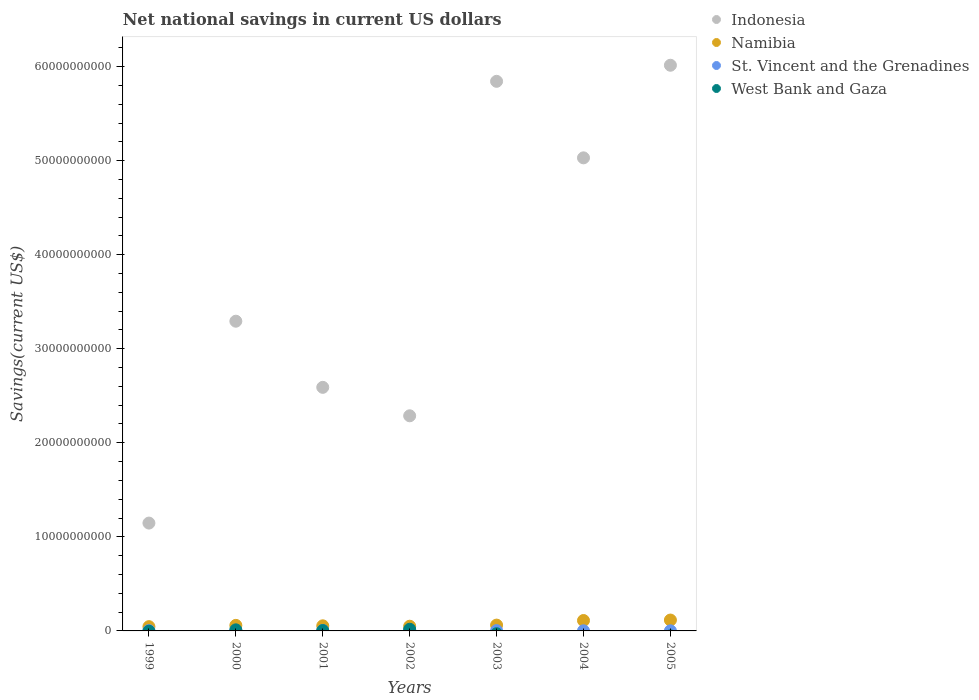How many different coloured dotlines are there?
Your answer should be compact. 4. Is the number of dotlines equal to the number of legend labels?
Give a very brief answer. No. What is the net national savings in St. Vincent and the Grenadines in 2000?
Offer a very short reply. 5.68e+07. Across all years, what is the maximum net national savings in West Bank and Gaza?
Offer a terse response. 1.78e+08. Across all years, what is the minimum net national savings in Indonesia?
Make the answer very short. 1.15e+1. In which year was the net national savings in Indonesia maximum?
Provide a succinct answer. 2005. What is the total net national savings in Indonesia in the graph?
Provide a short and direct response. 2.62e+11. What is the difference between the net national savings in Indonesia in 2002 and that in 2005?
Provide a short and direct response. -3.73e+1. What is the difference between the net national savings in Indonesia in 2004 and the net national savings in West Bank and Gaza in 2000?
Make the answer very short. 5.02e+1. What is the average net national savings in West Bank and Gaza per year?
Provide a succinct answer. 4.76e+07. In the year 2003, what is the difference between the net national savings in Namibia and net national savings in St. Vincent and the Grenadines?
Provide a succinct answer. 5.85e+08. In how many years, is the net national savings in Namibia greater than 56000000000 US$?
Offer a terse response. 0. What is the ratio of the net national savings in St. Vincent and the Grenadines in 2000 to that in 2001?
Keep it short and to the point. 1.23. What is the difference between the highest and the second highest net national savings in Indonesia?
Provide a short and direct response. 1.71e+09. What is the difference between the highest and the lowest net national savings in St. Vincent and the Grenadines?
Your answer should be compact. 4.45e+07. In how many years, is the net national savings in Namibia greater than the average net national savings in Namibia taken over all years?
Keep it short and to the point. 2. Is the sum of the net national savings in St. Vincent and the Grenadines in 2002 and 2004 greater than the maximum net national savings in Indonesia across all years?
Your answer should be very brief. No. Does the net national savings in Indonesia monotonically increase over the years?
Offer a very short reply. No. Is the net national savings in St. Vincent and the Grenadines strictly less than the net national savings in Namibia over the years?
Your answer should be compact. Yes. Are the values on the major ticks of Y-axis written in scientific E-notation?
Ensure brevity in your answer.  No. How many legend labels are there?
Provide a short and direct response. 4. How are the legend labels stacked?
Keep it short and to the point. Vertical. What is the title of the graph?
Give a very brief answer. Net national savings in current US dollars. What is the label or title of the X-axis?
Keep it short and to the point. Years. What is the label or title of the Y-axis?
Offer a very short reply. Savings(current US$). What is the Savings(current US$) of Indonesia in 1999?
Keep it short and to the point. 1.15e+1. What is the Savings(current US$) in Namibia in 1999?
Give a very brief answer. 4.54e+08. What is the Savings(current US$) of St. Vincent and the Grenadines in 1999?
Keep it short and to the point. 3.56e+07. What is the Savings(current US$) of Indonesia in 2000?
Your response must be concise. 3.29e+1. What is the Savings(current US$) of Namibia in 2000?
Offer a very short reply. 5.90e+08. What is the Savings(current US$) in St. Vincent and the Grenadines in 2000?
Your response must be concise. 5.68e+07. What is the Savings(current US$) in West Bank and Gaza in 2000?
Provide a succinct answer. 1.16e+08. What is the Savings(current US$) in Indonesia in 2001?
Keep it short and to the point. 2.59e+1. What is the Savings(current US$) in Namibia in 2001?
Make the answer very short. 5.42e+08. What is the Savings(current US$) in St. Vincent and the Grenadines in 2001?
Your answer should be compact. 4.61e+07. What is the Savings(current US$) of West Bank and Gaza in 2001?
Ensure brevity in your answer.  3.91e+07. What is the Savings(current US$) in Indonesia in 2002?
Ensure brevity in your answer.  2.29e+1. What is the Savings(current US$) of Namibia in 2002?
Your answer should be very brief. 5.00e+08. What is the Savings(current US$) in St. Vincent and the Grenadines in 2002?
Offer a very short reply. 4.76e+07. What is the Savings(current US$) of West Bank and Gaza in 2002?
Give a very brief answer. 1.78e+08. What is the Savings(current US$) in Indonesia in 2003?
Your response must be concise. 5.84e+1. What is the Savings(current US$) in Namibia in 2003?
Keep it short and to the point. 6.18e+08. What is the Savings(current US$) of St. Vincent and the Grenadines in 2003?
Keep it short and to the point. 3.32e+07. What is the Savings(current US$) in Indonesia in 2004?
Ensure brevity in your answer.  5.03e+1. What is the Savings(current US$) in Namibia in 2004?
Provide a short and direct response. 1.11e+09. What is the Savings(current US$) of St. Vincent and the Grenadines in 2004?
Offer a very short reply. 1.34e+07. What is the Savings(current US$) in West Bank and Gaza in 2004?
Provide a short and direct response. 0. What is the Savings(current US$) in Indonesia in 2005?
Offer a very short reply. 6.01e+1. What is the Savings(current US$) of Namibia in 2005?
Give a very brief answer. 1.16e+09. What is the Savings(current US$) in St. Vincent and the Grenadines in 2005?
Your answer should be very brief. 1.23e+07. Across all years, what is the maximum Savings(current US$) in Indonesia?
Provide a succinct answer. 6.01e+1. Across all years, what is the maximum Savings(current US$) in Namibia?
Your response must be concise. 1.16e+09. Across all years, what is the maximum Savings(current US$) in St. Vincent and the Grenadines?
Your answer should be compact. 5.68e+07. Across all years, what is the maximum Savings(current US$) in West Bank and Gaza?
Provide a short and direct response. 1.78e+08. Across all years, what is the minimum Savings(current US$) in Indonesia?
Ensure brevity in your answer.  1.15e+1. Across all years, what is the minimum Savings(current US$) in Namibia?
Ensure brevity in your answer.  4.54e+08. Across all years, what is the minimum Savings(current US$) in St. Vincent and the Grenadines?
Offer a terse response. 1.23e+07. Across all years, what is the minimum Savings(current US$) of West Bank and Gaza?
Your answer should be compact. 0. What is the total Savings(current US$) of Indonesia in the graph?
Provide a short and direct response. 2.62e+11. What is the total Savings(current US$) of Namibia in the graph?
Make the answer very short. 4.97e+09. What is the total Savings(current US$) of St. Vincent and the Grenadines in the graph?
Ensure brevity in your answer.  2.45e+08. What is the total Savings(current US$) in West Bank and Gaza in the graph?
Make the answer very short. 3.33e+08. What is the difference between the Savings(current US$) of Indonesia in 1999 and that in 2000?
Keep it short and to the point. -2.15e+1. What is the difference between the Savings(current US$) of Namibia in 1999 and that in 2000?
Give a very brief answer. -1.36e+08. What is the difference between the Savings(current US$) of St. Vincent and the Grenadines in 1999 and that in 2000?
Offer a terse response. -2.12e+07. What is the difference between the Savings(current US$) in Indonesia in 1999 and that in 2001?
Offer a very short reply. -1.44e+1. What is the difference between the Savings(current US$) of Namibia in 1999 and that in 2001?
Give a very brief answer. -8.80e+07. What is the difference between the Savings(current US$) of St. Vincent and the Grenadines in 1999 and that in 2001?
Ensure brevity in your answer.  -1.05e+07. What is the difference between the Savings(current US$) of Indonesia in 1999 and that in 2002?
Your answer should be compact. -1.14e+1. What is the difference between the Savings(current US$) in Namibia in 1999 and that in 2002?
Offer a terse response. -4.55e+07. What is the difference between the Savings(current US$) in St. Vincent and the Grenadines in 1999 and that in 2002?
Offer a terse response. -1.20e+07. What is the difference between the Savings(current US$) in Indonesia in 1999 and that in 2003?
Provide a succinct answer. -4.70e+1. What is the difference between the Savings(current US$) of Namibia in 1999 and that in 2003?
Ensure brevity in your answer.  -1.64e+08. What is the difference between the Savings(current US$) of St. Vincent and the Grenadines in 1999 and that in 2003?
Offer a terse response. 2.38e+06. What is the difference between the Savings(current US$) in Indonesia in 1999 and that in 2004?
Your response must be concise. -3.88e+1. What is the difference between the Savings(current US$) in Namibia in 1999 and that in 2004?
Keep it short and to the point. -6.52e+08. What is the difference between the Savings(current US$) in St. Vincent and the Grenadines in 1999 and that in 2004?
Ensure brevity in your answer.  2.22e+07. What is the difference between the Savings(current US$) in Indonesia in 1999 and that in 2005?
Offer a very short reply. -4.87e+1. What is the difference between the Savings(current US$) of Namibia in 1999 and that in 2005?
Keep it short and to the point. -7.01e+08. What is the difference between the Savings(current US$) in St. Vincent and the Grenadines in 1999 and that in 2005?
Ensure brevity in your answer.  2.33e+07. What is the difference between the Savings(current US$) of Indonesia in 2000 and that in 2001?
Keep it short and to the point. 7.03e+09. What is the difference between the Savings(current US$) in Namibia in 2000 and that in 2001?
Your answer should be compact. 4.76e+07. What is the difference between the Savings(current US$) in St. Vincent and the Grenadines in 2000 and that in 2001?
Your response must be concise. 1.07e+07. What is the difference between the Savings(current US$) in West Bank and Gaza in 2000 and that in 2001?
Make the answer very short. 7.66e+07. What is the difference between the Savings(current US$) of Indonesia in 2000 and that in 2002?
Your answer should be very brief. 1.01e+1. What is the difference between the Savings(current US$) in Namibia in 2000 and that in 2002?
Provide a succinct answer. 9.01e+07. What is the difference between the Savings(current US$) in St. Vincent and the Grenadines in 2000 and that in 2002?
Make the answer very short. 9.15e+06. What is the difference between the Savings(current US$) of West Bank and Gaza in 2000 and that in 2002?
Your answer should be compact. -6.26e+07. What is the difference between the Savings(current US$) of Indonesia in 2000 and that in 2003?
Offer a very short reply. -2.55e+1. What is the difference between the Savings(current US$) of Namibia in 2000 and that in 2003?
Make the answer very short. -2.83e+07. What is the difference between the Savings(current US$) of St. Vincent and the Grenadines in 2000 and that in 2003?
Make the answer very short. 2.36e+07. What is the difference between the Savings(current US$) of Indonesia in 2000 and that in 2004?
Provide a short and direct response. -1.74e+1. What is the difference between the Savings(current US$) of Namibia in 2000 and that in 2004?
Your answer should be very brief. -5.17e+08. What is the difference between the Savings(current US$) of St. Vincent and the Grenadines in 2000 and that in 2004?
Make the answer very short. 4.34e+07. What is the difference between the Savings(current US$) of Indonesia in 2000 and that in 2005?
Offer a very short reply. -2.72e+1. What is the difference between the Savings(current US$) in Namibia in 2000 and that in 2005?
Your answer should be very brief. -5.66e+08. What is the difference between the Savings(current US$) in St. Vincent and the Grenadines in 2000 and that in 2005?
Provide a short and direct response. 4.45e+07. What is the difference between the Savings(current US$) of Indonesia in 2001 and that in 2002?
Ensure brevity in your answer.  3.03e+09. What is the difference between the Savings(current US$) in Namibia in 2001 and that in 2002?
Your answer should be very brief. 4.25e+07. What is the difference between the Savings(current US$) in St. Vincent and the Grenadines in 2001 and that in 2002?
Provide a succinct answer. -1.51e+06. What is the difference between the Savings(current US$) of West Bank and Gaza in 2001 and that in 2002?
Keep it short and to the point. -1.39e+08. What is the difference between the Savings(current US$) in Indonesia in 2001 and that in 2003?
Your response must be concise. -3.25e+1. What is the difference between the Savings(current US$) of Namibia in 2001 and that in 2003?
Ensure brevity in your answer.  -7.59e+07. What is the difference between the Savings(current US$) of St. Vincent and the Grenadines in 2001 and that in 2003?
Ensure brevity in your answer.  1.29e+07. What is the difference between the Savings(current US$) in Indonesia in 2001 and that in 2004?
Offer a terse response. -2.44e+1. What is the difference between the Savings(current US$) in Namibia in 2001 and that in 2004?
Make the answer very short. -5.64e+08. What is the difference between the Savings(current US$) in St. Vincent and the Grenadines in 2001 and that in 2004?
Your answer should be very brief. 3.27e+07. What is the difference between the Savings(current US$) in Indonesia in 2001 and that in 2005?
Make the answer very short. -3.42e+1. What is the difference between the Savings(current US$) of Namibia in 2001 and that in 2005?
Make the answer very short. -6.13e+08. What is the difference between the Savings(current US$) of St. Vincent and the Grenadines in 2001 and that in 2005?
Give a very brief answer. 3.38e+07. What is the difference between the Savings(current US$) in Indonesia in 2002 and that in 2003?
Ensure brevity in your answer.  -3.56e+1. What is the difference between the Savings(current US$) in Namibia in 2002 and that in 2003?
Give a very brief answer. -1.18e+08. What is the difference between the Savings(current US$) of St. Vincent and the Grenadines in 2002 and that in 2003?
Your answer should be very brief. 1.44e+07. What is the difference between the Savings(current US$) in Indonesia in 2002 and that in 2004?
Your answer should be compact. -2.74e+1. What is the difference between the Savings(current US$) of Namibia in 2002 and that in 2004?
Offer a very short reply. -6.07e+08. What is the difference between the Savings(current US$) in St. Vincent and the Grenadines in 2002 and that in 2004?
Ensure brevity in your answer.  3.42e+07. What is the difference between the Savings(current US$) in Indonesia in 2002 and that in 2005?
Your answer should be very brief. -3.73e+1. What is the difference between the Savings(current US$) in Namibia in 2002 and that in 2005?
Offer a terse response. -6.56e+08. What is the difference between the Savings(current US$) in St. Vincent and the Grenadines in 2002 and that in 2005?
Ensure brevity in your answer.  3.53e+07. What is the difference between the Savings(current US$) in Indonesia in 2003 and that in 2004?
Your answer should be compact. 8.14e+09. What is the difference between the Savings(current US$) of Namibia in 2003 and that in 2004?
Make the answer very short. -4.88e+08. What is the difference between the Savings(current US$) of St. Vincent and the Grenadines in 2003 and that in 2004?
Your answer should be very brief. 1.98e+07. What is the difference between the Savings(current US$) in Indonesia in 2003 and that in 2005?
Provide a succinct answer. -1.71e+09. What is the difference between the Savings(current US$) in Namibia in 2003 and that in 2005?
Offer a terse response. -5.37e+08. What is the difference between the Savings(current US$) in St. Vincent and the Grenadines in 2003 and that in 2005?
Offer a very short reply. 2.09e+07. What is the difference between the Savings(current US$) of Indonesia in 2004 and that in 2005?
Offer a terse response. -9.85e+09. What is the difference between the Savings(current US$) in Namibia in 2004 and that in 2005?
Make the answer very short. -4.90e+07. What is the difference between the Savings(current US$) of St. Vincent and the Grenadines in 2004 and that in 2005?
Give a very brief answer. 1.10e+06. What is the difference between the Savings(current US$) in Indonesia in 1999 and the Savings(current US$) in Namibia in 2000?
Your answer should be compact. 1.09e+1. What is the difference between the Savings(current US$) of Indonesia in 1999 and the Savings(current US$) of St. Vincent and the Grenadines in 2000?
Offer a terse response. 1.14e+1. What is the difference between the Savings(current US$) in Indonesia in 1999 and the Savings(current US$) in West Bank and Gaza in 2000?
Keep it short and to the point. 1.14e+1. What is the difference between the Savings(current US$) of Namibia in 1999 and the Savings(current US$) of St. Vincent and the Grenadines in 2000?
Provide a short and direct response. 3.97e+08. What is the difference between the Savings(current US$) in Namibia in 1999 and the Savings(current US$) in West Bank and Gaza in 2000?
Your answer should be compact. 3.39e+08. What is the difference between the Savings(current US$) in St. Vincent and the Grenadines in 1999 and the Savings(current US$) in West Bank and Gaza in 2000?
Offer a very short reply. -8.01e+07. What is the difference between the Savings(current US$) of Indonesia in 1999 and the Savings(current US$) of Namibia in 2001?
Your answer should be very brief. 1.09e+1. What is the difference between the Savings(current US$) of Indonesia in 1999 and the Savings(current US$) of St. Vincent and the Grenadines in 2001?
Your response must be concise. 1.14e+1. What is the difference between the Savings(current US$) of Indonesia in 1999 and the Savings(current US$) of West Bank and Gaza in 2001?
Your answer should be very brief. 1.14e+1. What is the difference between the Savings(current US$) in Namibia in 1999 and the Savings(current US$) in St. Vincent and the Grenadines in 2001?
Your answer should be compact. 4.08e+08. What is the difference between the Savings(current US$) of Namibia in 1999 and the Savings(current US$) of West Bank and Gaza in 2001?
Your response must be concise. 4.15e+08. What is the difference between the Savings(current US$) in St. Vincent and the Grenadines in 1999 and the Savings(current US$) in West Bank and Gaza in 2001?
Make the answer very short. -3.47e+06. What is the difference between the Savings(current US$) of Indonesia in 1999 and the Savings(current US$) of Namibia in 2002?
Offer a very short reply. 1.10e+1. What is the difference between the Savings(current US$) of Indonesia in 1999 and the Savings(current US$) of St. Vincent and the Grenadines in 2002?
Your answer should be very brief. 1.14e+1. What is the difference between the Savings(current US$) of Indonesia in 1999 and the Savings(current US$) of West Bank and Gaza in 2002?
Your answer should be compact. 1.13e+1. What is the difference between the Savings(current US$) in Namibia in 1999 and the Savings(current US$) in St. Vincent and the Grenadines in 2002?
Offer a terse response. 4.07e+08. What is the difference between the Savings(current US$) of Namibia in 1999 and the Savings(current US$) of West Bank and Gaza in 2002?
Provide a short and direct response. 2.76e+08. What is the difference between the Savings(current US$) of St. Vincent and the Grenadines in 1999 and the Savings(current US$) of West Bank and Gaza in 2002?
Ensure brevity in your answer.  -1.43e+08. What is the difference between the Savings(current US$) of Indonesia in 1999 and the Savings(current US$) of Namibia in 2003?
Provide a succinct answer. 1.08e+1. What is the difference between the Savings(current US$) of Indonesia in 1999 and the Savings(current US$) of St. Vincent and the Grenadines in 2003?
Your answer should be very brief. 1.14e+1. What is the difference between the Savings(current US$) of Namibia in 1999 and the Savings(current US$) of St. Vincent and the Grenadines in 2003?
Make the answer very short. 4.21e+08. What is the difference between the Savings(current US$) of Indonesia in 1999 and the Savings(current US$) of Namibia in 2004?
Make the answer very short. 1.04e+1. What is the difference between the Savings(current US$) in Indonesia in 1999 and the Savings(current US$) in St. Vincent and the Grenadines in 2004?
Your answer should be compact. 1.15e+1. What is the difference between the Savings(current US$) of Namibia in 1999 and the Savings(current US$) of St. Vincent and the Grenadines in 2004?
Provide a short and direct response. 4.41e+08. What is the difference between the Savings(current US$) in Indonesia in 1999 and the Savings(current US$) in Namibia in 2005?
Provide a short and direct response. 1.03e+1. What is the difference between the Savings(current US$) in Indonesia in 1999 and the Savings(current US$) in St. Vincent and the Grenadines in 2005?
Provide a short and direct response. 1.15e+1. What is the difference between the Savings(current US$) of Namibia in 1999 and the Savings(current US$) of St. Vincent and the Grenadines in 2005?
Ensure brevity in your answer.  4.42e+08. What is the difference between the Savings(current US$) in Indonesia in 2000 and the Savings(current US$) in Namibia in 2001?
Your response must be concise. 3.24e+1. What is the difference between the Savings(current US$) of Indonesia in 2000 and the Savings(current US$) of St. Vincent and the Grenadines in 2001?
Your response must be concise. 3.29e+1. What is the difference between the Savings(current US$) in Indonesia in 2000 and the Savings(current US$) in West Bank and Gaza in 2001?
Ensure brevity in your answer.  3.29e+1. What is the difference between the Savings(current US$) in Namibia in 2000 and the Savings(current US$) in St. Vincent and the Grenadines in 2001?
Offer a terse response. 5.44e+08. What is the difference between the Savings(current US$) of Namibia in 2000 and the Savings(current US$) of West Bank and Gaza in 2001?
Ensure brevity in your answer.  5.51e+08. What is the difference between the Savings(current US$) in St. Vincent and the Grenadines in 2000 and the Savings(current US$) in West Bank and Gaza in 2001?
Make the answer very short. 1.77e+07. What is the difference between the Savings(current US$) in Indonesia in 2000 and the Savings(current US$) in Namibia in 2002?
Your response must be concise. 3.24e+1. What is the difference between the Savings(current US$) in Indonesia in 2000 and the Savings(current US$) in St. Vincent and the Grenadines in 2002?
Provide a short and direct response. 3.29e+1. What is the difference between the Savings(current US$) of Indonesia in 2000 and the Savings(current US$) of West Bank and Gaza in 2002?
Offer a very short reply. 3.27e+1. What is the difference between the Savings(current US$) of Namibia in 2000 and the Savings(current US$) of St. Vincent and the Grenadines in 2002?
Keep it short and to the point. 5.42e+08. What is the difference between the Savings(current US$) in Namibia in 2000 and the Savings(current US$) in West Bank and Gaza in 2002?
Provide a succinct answer. 4.12e+08. What is the difference between the Savings(current US$) in St. Vincent and the Grenadines in 2000 and the Savings(current US$) in West Bank and Gaza in 2002?
Ensure brevity in your answer.  -1.22e+08. What is the difference between the Savings(current US$) in Indonesia in 2000 and the Savings(current US$) in Namibia in 2003?
Provide a succinct answer. 3.23e+1. What is the difference between the Savings(current US$) in Indonesia in 2000 and the Savings(current US$) in St. Vincent and the Grenadines in 2003?
Ensure brevity in your answer.  3.29e+1. What is the difference between the Savings(current US$) of Namibia in 2000 and the Savings(current US$) of St. Vincent and the Grenadines in 2003?
Offer a very short reply. 5.57e+08. What is the difference between the Savings(current US$) of Indonesia in 2000 and the Savings(current US$) of Namibia in 2004?
Offer a terse response. 3.18e+1. What is the difference between the Savings(current US$) of Indonesia in 2000 and the Savings(current US$) of St. Vincent and the Grenadines in 2004?
Offer a very short reply. 3.29e+1. What is the difference between the Savings(current US$) in Namibia in 2000 and the Savings(current US$) in St. Vincent and the Grenadines in 2004?
Keep it short and to the point. 5.76e+08. What is the difference between the Savings(current US$) of Indonesia in 2000 and the Savings(current US$) of Namibia in 2005?
Ensure brevity in your answer.  3.18e+1. What is the difference between the Savings(current US$) of Indonesia in 2000 and the Savings(current US$) of St. Vincent and the Grenadines in 2005?
Your response must be concise. 3.29e+1. What is the difference between the Savings(current US$) of Namibia in 2000 and the Savings(current US$) of St. Vincent and the Grenadines in 2005?
Offer a very short reply. 5.78e+08. What is the difference between the Savings(current US$) in Indonesia in 2001 and the Savings(current US$) in Namibia in 2002?
Keep it short and to the point. 2.54e+1. What is the difference between the Savings(current US$) in Indonesia in 2001 and the Savings(current US$) in St. Vincent and the Grenadines in 2002?
Keep it short and to the point. 2.58e+1. What is the difference between the Savings(current US$) of Indonesia in 2001 and the Savings(current US$) of West Bank and Gaza in 2002?
Your response must be concise. 2.57e+1. What is the difference between the Savings(current US$) of Namibia in 2001 and the Savings(current US$) of St. Vincent and the Grenadines in 2002?
Offer a very short reply. 4.95e+08. What is the difference between the Savings(current US$) in Namibia in 2001 and the Savings(current US$) in West Bank and Gaza in 2002?
Make the answer very short. 3.64e+08. What is the difference between the Savings(current US$) in St. Vincent and the Grenadines in 2001 and the Savings(current US$) in West Bank and Gaza in 2002?
Give a very brief answer. -1.32e+08. What is the difference between the Savings(current US$) of Indonesia in 2001 and the Savings(current US$) of Namibia in 2003?
Your answer should be compact. 2.53e+1. What is the difference between the Savings(current US$) in Indonesia in 2001 and the Savings(current US$) in St. Vincent and the Grenadines in 2003?
Make the answer very short. 2.59e+1. What is the difference between the Savings(current US$) of Namibia in 2001 and the Savings(current US$) of St. Vincent and the Grenadines in 2003?
Provide a succinct answer. 5.09e+08. What is the difference between the Savings(current US$) in Indonesia in 2001 and the Savings(current US$) in Namibia in 2004?
Make the answer very short. 2.48e+1. What is the difference between the Savings(current US$) of Indonesia in 2001 and the Savings(current US$) of St. Vincent and the Grenadines in 2004?
Keep it short and to the point. 2.59e+1. What is the difference between the Savings(current US$) of Namibia in 2001 and the Savings(current US$) of St. Vincent and the Grenadines in 2004?
Your answer should be compact. 5.29e+08. What is the difference between the Savings(current US$) in Indonesia in 2001 and the Savings(current US$) in Namibia in 2005?
Provide a succinct answer. 2.47e+1. What is the difference between the Savings(current US$) of Indonesia in 2001 and the Savings(current US$) of St. Vincent and the Grenadines in 2005?
Keep it short and to the point. 2.59e+1. What is the difference between the Savings(current US$) in Namibia in 2001 and the Savings(current US$) in St. Vincent and the Grenadines in 2005?
Keep it short and to the point. 5.30e+08. What is the difference between the Savings(current US$) of Indonesia in 2002 and the Savings(current US$) of Namibia in 2003?
Provide a short and direct response. 2.23e+1. What is the difference between the Savings(current US$) of Indonesia in 2002 and the Savings(current US$) of St. Vincent and the Grenadines in 2003?
Your answer should be compact. 2.28e+1. What is the difference between the Savings(current US$) of Namibia in 2002 and the Savings(current US$) of St. Vincent and the Grenadines in 2003?
Your answer should be very brief. 4.67e+08. What is the difference between the Savings(current US$) in Indonesia in 2002 and the Savings(current US$) in Namibia in 2004?
Provide a succinct answer. 2.18e+1. What is the difference between the Savings(current US$) of Indonesia in 2002 and the Savings(current US$) of St. Vincent and the Grenadines in 2004?
Offer a very short reply. 2.29e+1. What is the difference between the Savings(current US$) in Namibia in 2002 and the Savings(current US$) in St. Vincent and the Grenadines in 2004?
Your answer should be very brief. 4.86e+08. What is the difference between the Savings(current US$) of Indonesia in 2002 and the Savings(current US$) of Namibia in 2005?
Provide a short and direct response. 2.17e+1. What is the difference between the Savings(current US$) of Indonesia in 2002 and the Savings(current US$) of St. Vincent and the Grenadines in 2005?
Provide a short and direct response. 2.29e+1. What is the difference between the Savings(current US$) in Namibia in 2002 and the Savings(current US$) in St. Vincent and the Grenadines in 2005?
Your answer should be very brief. 4.87e+08. What is the difference between the Savings(current US$) in Indonesia in 2003 and the Savings(current US$) in Namibia in 2004?
Provide a succinct answer. 5.73e+1. What is the difference between the Savings(current US$) of Indonesia in 2003 and the Savings(current US$) of St. Vincent and the Grenadines in 2004?
Make the answer very short. 5.84e+1. What is the difference between the Savings(current US$) in Namibia in 2003 and the Savings(current US$) in St. Vincent and the Grenadines in 2004?
Make the answer very short. 6.05e+08. What is the difference between the Savings(current US$) in Indonesia in 2003 and the Savings(current US$) in Namibia in 2005?
Your answer should be compact. 5.73e+1. What is the difference between the Savings(current US$) of Indonesia in 2003 and the Savings(current US$) of St. Vincent and the Grenadines in 2005?
Provide a short and direct response. 5.84e+1. What is the difference between the Savings(current US$) of Namibia in 2003 and the Savings(current US$) of St. Vincent and the Grenadines in 2005?
Make the answer very short. 6.06e+08. What is the difference between the Savings(current US$) in Indonesia in 2004 and the Savings(current US$) in Namibia in 2005?
Your answer should be compact. 4.91e+1. What is the difference between the Savings(current US$) in Indonesia in 2004 and the Savings(current US$) in St. Vincent and the Grenadines in 2005?
Give a very brief answer. 5.03e+1. What is the difference between the Savings(current US$) in Namibia in 2004 and the Savings(current US$) in St. Vincent and the Grenadines in 2005?
Your answer should be very brief. 1.09e+09. What is the average Savings(current US$) in Indonesia per year?
Provide a succinct answer. 3.74e+1. What is the average Savings(current US$) of Namibia per year?
Give a very brief answer. 7.09e+08. What is the average Savings(current US$) in St. Vincent and the Grenadines per year?
Your answer should be very brief. 3.50e+07. What is the average Savings(current US$) of West Bank and Gaza per year?
Give a very brief answer. 4.76e+07. In the year 1999, what is the difference between the Savings(current US$) in Indonesia and Savings(current US$) in Namibia?
Provide a short and direct response. 1.10e+1. In the year 1999, what is the difference between the Savings(current US$) of Indonesia and Savings(current US$) of St. Vincent and the Grenadines?
Provide a short and direct response. 1.14e+1. In the year 1999, what is the difference between the Savings(current US$) of Namibia and Savings(current US$) of St. Vincent and the Grenadines?
Keep it short and to the point. 4.19e+08. In the year 2000, what is the difference between the Savings(current US$) of Indonesia and Savings(current US$) of Namibia?
Offer a very short reply. 3.23e+1. In the year 2000, what is the difference between the Savings(current US$) of Indonesia and Savings(current US$) of St. Vincent and the Grenadines?
Your answer should be compact. 3.29e+1. In the year 2000, what is the difference between the Savings(current US$) of Indonesia and Savings(current US$) of West Bank and Gaza?
Provide a short and direct response. 3.28e+1. In the year 2000, what is the difference between the Savings(current US$) in Namibia and Savings(current US$) in St. Vincent and the Grenadines?
Your answer should be very brief. 5.33e+08. In the year 2000, what is the difference between the Savings(current US$) of Namibia and Savings(current US$) of West Bank and Gaza?
Ensure brevity in your answer.  4.74e+08. In the year 2000, what is the difference between the Savings(current US$) of St. Vincent and the Grenadines and Savings(current US$) of West Bank and Gaza?
Your answer should be very brief. -5.89e+07. In the year 2001, what is the difference between the Savings(current US$) in Indonesia and Savings(current US$) in Namibia?
Your answer should be compact. 2.54e+1. In the year 2001, what is the difference between the Savings(current US$) in Indonesia and Savings(current US$) in St. Vincent and the Grenadines?
Make the answer very short. 2.59e+1. In the year 2001, what is the difference between the Savings(current US$) in Indonesia and Savings(current US$) in West Bank and Gaza?
Provide a short and direct response. 2.59e+1. In the year 2001, what is the difference between the Savings(current US$) in Namibia and Savings(current US$) in St. Vincent and the Grenadines?
Offer a terse response. 4.96e+08. In the year 2001, what is the difference between the Savings(current US$) in Namibia and Savings(current US$) in West Bank and Gaza?
Your answer should be compact. 5.03e+08. In the year 2001, what is the difference between the Savings(current US$) of St. Vincent and the Grenadines and Savings(current US$) of West Bank and Gaza?
Provide a short and direct response. 7.04e+06. In the year 2002, what is the difference between the Savings(current US$) in Indonesia and Savings(current US$) in Namibia?
Offer a very short reply. 2.24e+1. In the year 2002, what is the difference between the Savings(current US$) in Indonesia and Savings(current US$) in St. Vincent and the Grenadines?
Provide a succinct answer. 2.28e+1. In the year 2002, what is the difference between the Savings(current US$) in Indonesia and Savings(current US$) in West Bank and Gaza?
Give a very brief answer. 2.27e+1. In the year 2002, what is the difference between the Savings(current US$) of Namibia and Savings(current US$) of St. Vincent and the Grenadines?
Provide a succinct answer. 4.52e+08. In the year 2002, what is the difference between the Savings(current US$) in Namibia and Savings(current US$) in West Bank and Gaza?
Your response must be concise. 3.21e+08. In the year 2002, what is the difference between the Savings(current US$) in St. Vincent and the Grenadines and Savings(current US$) in West Bank and Gaza?
Offer a very short reply. -1.31e+08. In the year 2003, what is the difference between the Savings(current US$) of Indonesia and Savings(current US$) of Namibia?
Your response must be concise. 5.78e+1. In the year 2003, what is the difference between the Savings(current US$) of Indonesia and Savings(current US$) of St. Vincent and the Grenadines?
Your answer should be very brief. 5.84e+1. In the year 2003, what is the difference between the Savings(current US$) in Namibia and Savings(current US$) in St. Vincent and the Grenadines?
Your answer should be compact. 5.85e+08. In the year 2004, what is the difference between the Savings(current US$) in Indonesia and Savings(current US$) in Namibia?
Your answer should be very brief. 4.92e+1. In the year 2004, what is the difference between the Savings(current US$) in Indonesia and Savings(current US$) in St. Vincent and the Grenadines?
Provide a succinct answer. 5.03e+1. In the year 2004, what is the difference between the Savings(current US$) in Namibia and Savings(current US$) in St. Vincent and the Grenadines?
Give a very brief answer. 1.09e+09. In the year 2005, what is the difference between the Savings(current US$) in Indonesia and Savings(current US$) in Namibia?
Offer a very short reply. 5.90e+1. In the year 2005, what is the difference between the Savings(current US$) in Indonesia and Savings(current US$) in St. Vincent and the Grenadines?
Ensure brevity in your answer.  6.01e+1. In the year 2005, what is the difference between the Savings(current US$) in Namibia and Savings(current US$) in St. Vincent and the Grenadines?
Your response must be concise. 1.14e+09. What is the ratio of the Savings(current US$) of Indonesia in 1999 to that in 2000?
Give a very brief answer. 0.35. What is the ratio of the Savings(current US$) of Namibia in 1999 to that in 2000?
Keep it short and to the point. 0.77. What is the ratio of the Savings(current US$) in St. Vincent and the Grenadines in 1999 to that in 2000?
Give a very brief answer. 0.63. What is the ratio of the Savings(current US$) of Indonesia in 1999 to that in 2001?
Keep it short and to the point. 0.44. What is the ratio of the Savings(current US$) in Namibia in 1999 to that in 2001?
Keep it short and to the point. 0.84. What is the ratio of the Savings(current US$) in St. Vincent and the Grenadines in 1999 to that in 2001?
Keep it short and to the point. 0.77. What is the ratio of the Savings(current US$) in Indonesia in 1999 to that in 2002?
Ensure brevity in your answer.  0.5. What is the ratio of the Savings(current US$) in Namibia in 1999 to that in 2002?
Your answer should be compact. 0.91. What is the ratio of the Savings(current US$) of St. Vincent and the Grenadines in 1999 to that in 2002?
Keep it short and to the point. 0.75. What is the ratio of the Savings(current US$) in Indonesia in 1999 to that in 2003?
Your response must be concise. 0.2. What is the ratio of the Savings(current US$) of Namibia in 1999 to that in 2003?
Offer a terse response. 0.73. What is the ratio of the Savings(current US$) of St. Vincent and the Grenadines in 1999 to that in 2003?
Give a very brief answer. 1.07. What is the ratio of the Savings(current US$) of Indonesia in 1999 to that in 2004?
Make the answer very short. 0.23. What is the ratio of the Savings(current US$) in Namibia in 1999 to that in 2004?
Your answer should be very brief. 0.41. What is the ratio of the Savings(current US$) of St. Vincent and the Grenadines in 1999 to that in 2004?
Make the answer very short. 2.65. What is the ratio of the Savings(current US$) in Indonesia in 1999 to that in 2005?
Your answer should be compact. 0.19. What is the ratio of the Savings(current US$) in Namibia in 1999 to that in 2005?
Provide a succinct answer. 0.39. What is the ratio of the Savings(current US$) in St. Vincent and the Grenadines in 1999 to that in 2005?
Make the answer very short. 2.89. What is the ratio of the Savings(current US$) of Indonesia in 2000 to that in 2001?
Your answer should be compact. 1.27. What is the ratio of the Savings(current US$) of Namibia in 2000 to that in 2001?
Provide a short and direct response. 1.09. What is the ratio of the Savings(current US$) in St. Vincent and the Grenadines in 2000 to that in 2001?
Keep it short and to the point. 1.23. What is the ratio of the Savings(current US$) in West Bank and Gaza in 2000 to that in 2001?
Give a very brief answer. 2.96. What is the ratio of the Savings(current US$) in Indonesia in 2000 to that in 2002?
Provide a succinct answer. 1.44. What is the ratio of the Savings(current US$) in Namibia in 2000 to that in 2002?
Offer a very short reply. 1.18. What is the ratio of the Savings(current US$) of St. Vincent and the Grenadines in 2000 to that in 2002?
Your answer should be very brief. 1.19. What is the ratio of the Savings(current US$) of West Bank and Gaza in 2000 to that in 2002?
Ensure brevity in your answer.  0.65. What is the ratio of the Savings(current US$) in Indonesia in 2000 to that in 2003?
Make the answer very short. 0.56. What is the ratio of the Savings(current US$) of Namibia in 2000 to that in 2003?
Ensure brevity in your answer.  0.95. What is the ratio of the Savings(current US$) in St. Vincent and the Grenadines in 2000 to that in 2003?
Offer a very short reply. 1.71. What is the ratio of the Savings(current US$) of Indonesia in 2000 to that in 2004?
Ensure brevity in your answer.  0.65. What is the ratio of the Savings(current US$) of Namibia in 2000 to that in 2004?
Ensure brevity in your answer.  0.53. What is the ratio of the Savings(current US$) of St. Vincent and the Grenadines in 2000 to that in 2004?
Offer a very short reply. 4.23. What is the ratio of the Savings(current US$) of Indonesia in 2000 to that in 2005?
Keep it short and to the point. 0.55. What is the ratio of the Savings(current US$) in Namibia in 2000 to that in 2005?
Offer a terse response. 0.51. What is the ratio of the Savings(current US$) of St. Vincent and the Grenadines in 2000 to that in 2005?
Ensure brevity in your answer.  4.61. What is the ratio of the Savings(current US$) of Indonesia in 2001 to that in 2002?
Keep it short and to the point. 1.13. What is the ratio of the Savings(current US$) of Namibia in 2001 to that in 2002?
Ensure brevity in your answer.  1.08. What is the ratio of the Savings(current US$) of St. Vincent and the Grenadines in 2001 to that in 2002?
Provide a succinct answer. 0.97. What is the ratio of the Savings(current US$) of West Bank and Gaza in 2001 to that in 2002?
Keep it short and to the point. 0.22. What is the ratio of the Savings(current US$) in Indonesia in 2001 to that in 2003?
Provide a short and direct response. 0.44. What is the ratio of the Savings(current US$) in Namibia in 2001 to that in 2003?
Your answer should be compact. 0.88. What is the ratio of the Savings(current US$) of St. Vincent and the Grenadines in 2001 to that in 2003?
Make the answer very short. 1.39. What is the ratio of the Savings(current US$) in Indonesia in 2001 to that in 2004?
Provide a succinct answer. 0.51. What is the ratio of the Savings(current US$) of Namibia in 2001 to that in 2004?
Offer a terse response. 0.49. What is the ratio of the Savings(current US$) in St. Vincent and the Grenadines in 2001 to that in 2004?
Give a very brief answer. 3.44. What is the ratio of the Savings(current US$) of Indonesia in 2001 to that in 2005?
Your answer should be compact. 0.43. What is the ratio of the Savings(current US$) in Namibia in 2001 to that in 2005?
Provide a succinct answer. 0.47. What is the ratio of the Savings(current US$) of St. Vincent and the Grenadines in 2001 to that in 2005?
Provide a succinct answer. 3.75. What is the ratio of the Savings(current US$) in Indonesia in 2002 to that in 2003?
Your answer should be very brief. 0.39. What is the ratio of the Savings(current US$) in Namibia in 2002 to that in 2003?
Keep it short and to the point. 0.81. What is the ratio of the Savings(current US$) in St. Vincent and the Grenadines in 2002 to that in 2003?
Provide a succinct answer. 1.43. What is the ratio of the Savings(current US$) of Indonesia in 2002 to that in 2004?
Your response must be concise. 0.45. What is the ratio of the Savings(current US$) of Namibia in 2002 to that in 2004?
Your answer should be very brief. 0.45. What is the ratio of the Savings(current US$) of St. Vincent and the Grenadines in 2002 to that in 2004?
Provide a short and direct response. 3.55. What is the ratio of the Savings(current US$) in Indonesia in 2002 to that in 2005?
Offer a very short reply. 0.38. What is the ratio of the Savings(current US$) of Namibia in 2002 to that in 2005?
Offer a very short reply. 0.43. What is the ratio of the Savings(current US$) of St. Vincent and the Grenadines in 2002 to that in 2005?
Your answer should be compact. 3.87. What is the ratio of the Savings(current US$) of Indonesia in 2003 to that in 2004?
Your answer should be very brief. 1.16. What is the ratio of the Savings(current US$) in Namibia in 2003 to that in 2004?
Your response must be concise. 0.56. What is the ratio of the Savings(current US$) in St. Vincent and the Grenadines in 2003 to that in 2004?
Offer a terse response. 2.48. What is the ratio of the Savings(current US$) in Indonesia in 2003 to that in 2005?
Provide a short and direct response. 0.97. What is the ratio of the Savings(current US$) in Namibia in 2003 to that in 2005?
Ensure brevity in your answer.  0.54. What is the ratio of the Savings(current US$) in St. Vincent and the Grenadines in 2003 to that in 2005?
Ensure brevity in your answer.  2.7. What is the ratio of the Savings(current US$) in Indonesia in 2004 to that in 2005?
Offer a terse response. 0.84. What is the ratio of the Savings(current US$) of Namibia in 2004 to that in 2005?
Keep it short and to the point. 0.96. What is the ratio of the Savings(current US$) in St. Vincent and the Grenadines in 2004 to that in 2005?
Your response must be concise. 1.09. What is the difference between the highest and the second highest Savings(current US$) in Indonesia?
Your answer should be compact. 1.71e+09. What is the difference between the highest and the second highest Savings(current US$) in Namibia?
Your answer should be compact. 4.90e+07. What is the difference between the highest and the second highest Savings(current US$) of St. Vincent and the Grenadines?
Your answer should be very brief. 9.15e+06. What is the difference between the highest and the second highest Savings(current US$) in West Bank and Gaza?
Make the answer very short. 6.26e+07. What is the difference between the highest and the lowest Savings(current US$) of Indonesia?
Your response must be concise. 4.87e+1. What is the difference between the highest and the lowest Savings(current US$) of Namibia?
Offer a very short reply. 7.01e+08. What is the difference between the highest and the lowest Savings(current US$) of St. Vincent and the Grenadines?
Your response must be concise. 4.45e+07. What is the difference between the highest and the lowest Savings(current US$) of West Bank and Gaza?
Provide a short and direct response. 1.78e+08. 